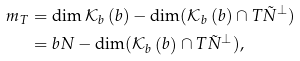<formula> <loc_0><loc_0><loc_500><loc_500>m _ { T } & = \dim \mathcal { K } _ { b } \left ( b \right ) - \dim ( \mathcal { K } _ { b } \left ( b \right ) \cap T \tilde { N } ^ { \perp } ) \\ & = b N - \dim ( \mathcal { K } _ { b } \left ( b \right ) \cap T \tilde { N } ^ { \perp } ) ,</formula> 